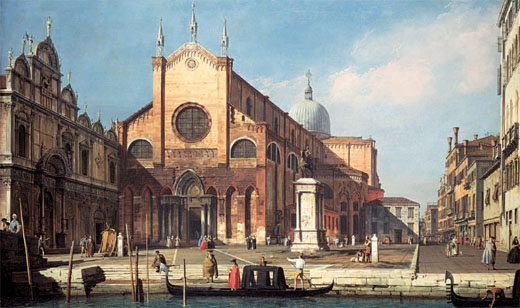What fantasy elements could this scene incorporate to transform it into a magical land? Envisioning this Venetian cityscape as a magical land, one could introduce a host of enchanting elements. The grand church in the center could be crowned with a luminous crystal dome that sparkles with every passing ray of sunlight, perhaps even casting colorful rainbows across the square. Floating lanterns could drift above the city, illuminating the streets with a soft, ethereal glow come nightfall. The canal waters might shimmer with bioluminescent creatures, guiding gondolas gently with their glow. Mythical beings like elegant elves or mysterious water nymphs could be seen mingling with the city's inhabitants, adding a fantastical dimension. Flowers and vines, with blossoms that change color through the day, could drape the buildings, infusing the air with a mesmerising fragrance. Every corner of this magical Venice would pulse with wonder and enchantment, transforming the ordinary into the extraordinary. 